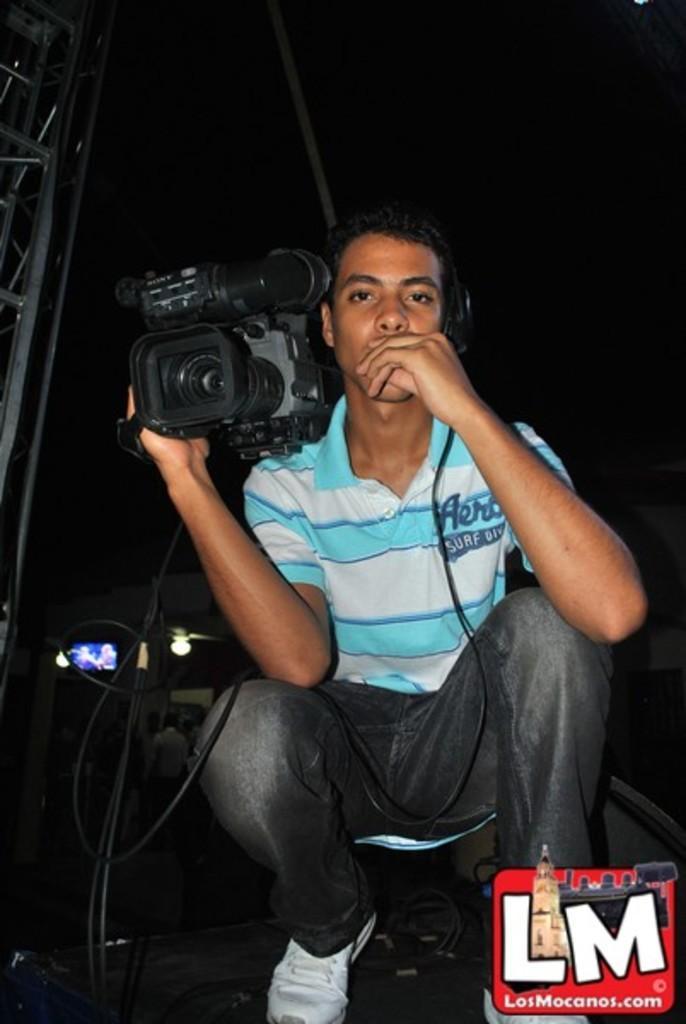In one or two sentences, can you explain what this image depicts? In this picture we can see a man who is holding a camera with his hand. And this is light. 